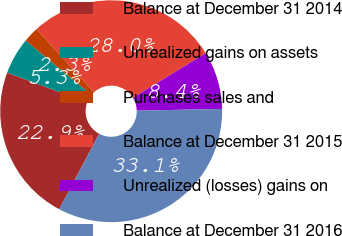<chart> <loc_0><loc_0><loc_500><loc_500><pie_chart><fcel>Balance at December 31 2014<fcel>Unrealized gains on assets<fcel>Purchases sales and<fcel>Balance at December 31 2015<fcel>Unrealized (losses) gains on<fcel>Balance at December 31 2016<nl><fcel>22.9%<fcel>5.34%<fcel>2.26%<fcel>27.99%<fcel>8.43%<fcel>33.08%<nl></chart> 